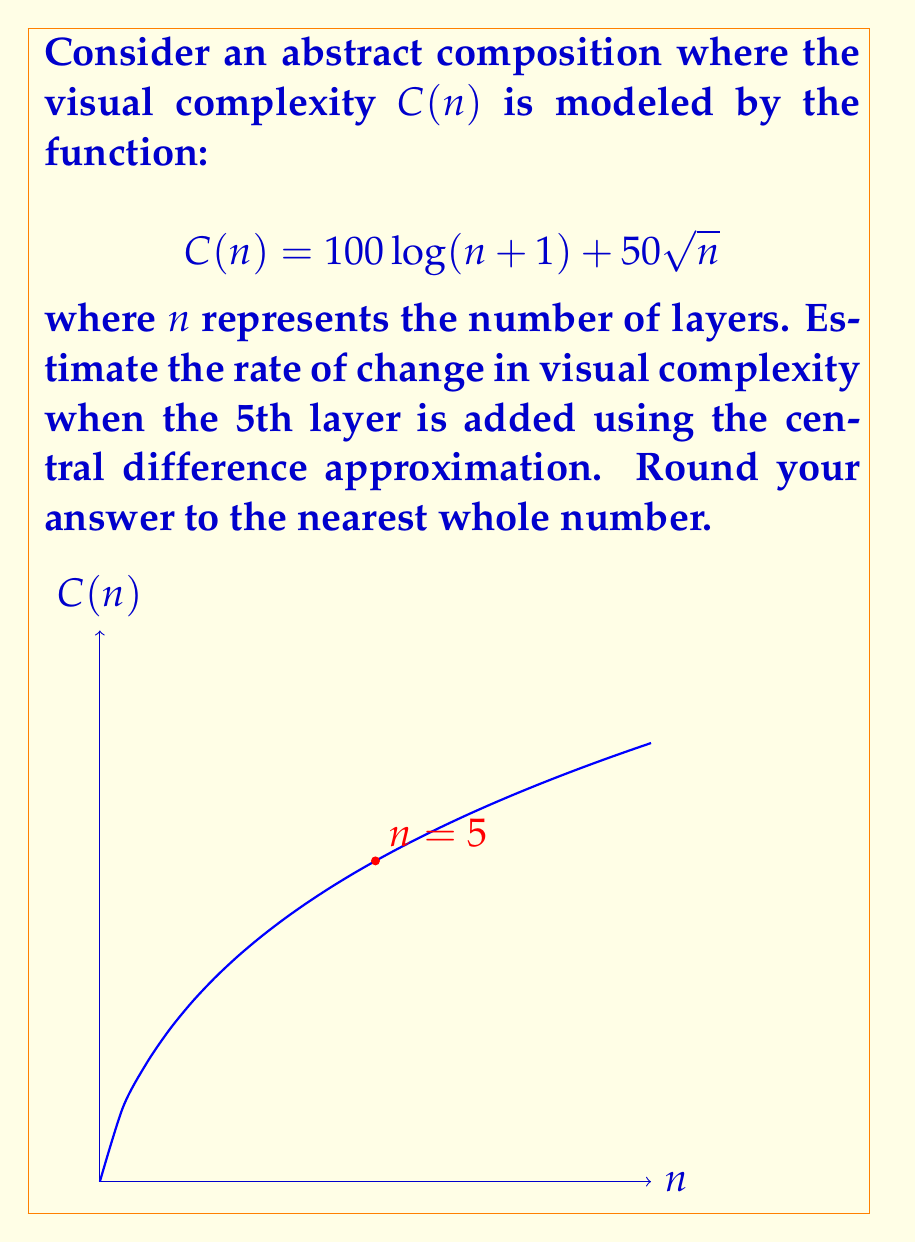Can you solve this math problem? To estimate the rate of change in visual complexity when the 5th layer is added, we'll use the central difference approximation:

$$f'(x) \approx \frac{f(x+h) - f(x-h)}{2h}$$

Where $h=1$ (since we're dealing with discrete layers), and $x=5$.

Step 1: Calculate $C(6)$ and $C(4)$
$$C(6) = 100 \log(7) + 50\sqrt{6} = 194.59 + 122.47 = 317.06$$
$$C(4) = 100 \log(5) + 50\sqrt{4} = 160.94 + 100 = 260.94$$

Step 2: Apply the central difference formula
$$\frac{dC}{dn}\bigg|_{n=5} \approx \frac{C(6) - C(4)}{2(1)} = \frac{317.06 - 260.94}{2} = 28.06$$

Step 3: Round to the nearest whole number
$$28.06 \approx 28$$

Therefore, the estimated rate of change in visual complexity when the 5th layer is added is approximately 28 units per layer.
Answer: 28 